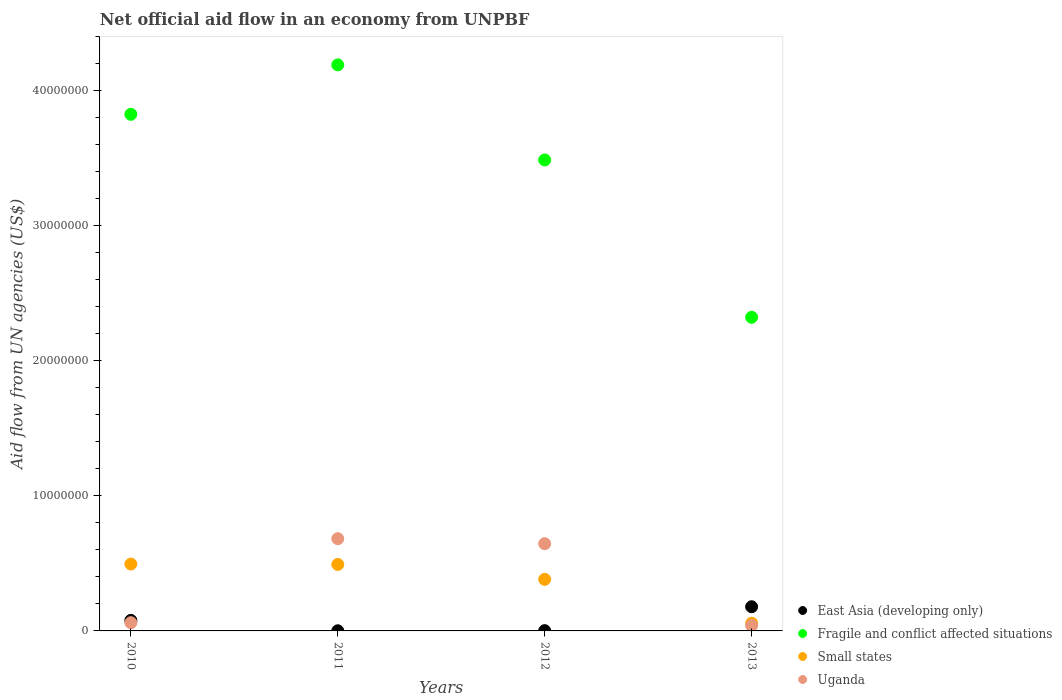What is the net official aid flow in Small states in 2010?
Provide a succinct answer. 4.95e+06. Across all years, what is the maximum net official aid flow in East Asia (developing only)?
Provide a succinct answer. 1.79e+06. Across all years, what is the minimum net official aid flow in Small states?
Offer a very short reply. 5.70e+05. In which year was the net official aid flow in Small states minimum?
Your answer should be compact. 2013. What is the total net official aid flow in Uganda in the graph?
Offer a very short reply. 1.43e+07. What is the difference between the net official aid flow in Uganda in 2011 and that in 2012?
Your answer should be very brief. 3.70e+05. What is the difference between the net official aid flow in Fragile and conflict affected situations in 2010 and the net official aid flow in Small states in 2012?
Make the answer very short. 3.44e+07. What is the average net official aid flow in East Asia (developing only) per year?
Keep it short and to the point. 6.50e+05. In the year 2012, what is the difference between the net official aid flow in Uganda and net official aid flow in East Asia (developing only)?
Provide a short and direct response. 6.44e+06. What is the ratio of the net official aid flow in East Asia (developing only) in 2010 to that in 2013?
Your answer should be very brief. 0.44. Is the net official aid flow in Fragile and conflict affected situations in 2010 less than that in 2013?
Provide a short and direct response. No. What is the difference between the highest and the second highest net official aid flow in East Asia (developing only)?
Provide a short and direct response. 1.01e+06. What is the difference between the highest and the lowest net official aid flow in Fragile and conflict affected situations?
Give a very brief answer. 1.87e+07. Is the sum of the net official aid flow in Uganda in 2012 and 2013 greater than the maximum net official aid flow in Fragile and conflict affected situations across all years?
Provide a short and direct response. No. Is it the case that in every year, the sum of the net official aid flow in Small states and net official aid flow in Uganda  is greater than the sum of net official aid flow in Fragile and conflict affected situations and net official aid flow in East Asia (developing only)?
Give a very brief answer. No. Is the net official aid flow in Fragile and conflict affected situations strictly greater than the net official aid flow in East Asia (developing only) over the years?
Ensure brevity in your answer.  Yes. Is the net official aid flow in East Asia (developing only) strictly less than the net official aid flow in Uganda over the years?
Give a very brief answer. No. How many dotlines are there?
Keep it short and to the point. 4. What is the difference between two consecutive major ticks on the Y-axis?
Provide a succinct answer. 1.00e+07. Does the graph contain any zero values?
Provide a short and direct response. No. Where does the legend appear in the graph?
Offer a terse response. Bottom right. How many legend labels are there?
Provide a succinct answer. 4. What is the title of the graph?
Provide a succinct answer. Net official aid flow in an economy from UNPBF. Does "Norway" appear as one of the legend labels in the graph?
Offer a terse response. No. What is the label or title of the X-axis?
Offer a very short reply. Years. What is the label or title of the Y-axis?
Provide a short and direct response. Aid flow from UN agencies (US$). What is the Aid flow from UN agencies (US$) of East Asia (developing only) in 2010?
Ensure brevity in your answer.  7.80e+05. What is the Aid flow from UN agencies (US$) in Fragile and conflict affected situations in 2010?
Provide a short and direct response. 3.82e+07. What is the Aid flow from UN agencies (US$) of Small states in 2010?
Provide a succinct answer. 4.95e+06. What is the Aid flow from UN agencies (US$) of Uganda in 2010?
Give a very brief answer. 6.10e+05. What is the Aid flow from UN agencies (US$) in Fragile and conflict affected situations in 2011?
Your response must be concise. 4.19e+07. What is the Aid flow from UN agencies (US$) in Small states in 2011?
Provide a succinct answer. 4.92e+06. What is the Aid flow from UN agencies (US$) of Uganda in 2011?
Offer a terse response. 6.83e+06. What is the Aid flow from UN agencies (US$) in Fragile and conflict affected situations in 2012?
Keep it short and to the point. 3.49e+07. What is the Aid flow from UN agencies (US$) in Small states in 2012?
Offer a terse response. 3.82e+06. What is the Aid flow from UN agencies (US$) of Uganda in 2012?
Keep it short and to the point. 6.46e+06. What is the Aid flow from UN agencies (US$) in East Asia (developing only) in 2013?
Make the answer very short. 1.79e+06. What is the Aid flow from UN agencies (US$) of Fragile and conflict affected situations in 2013?
Make the answer very short. 2.32e+07. What is the Aid flow from UN agencies (US$) of Small states in 2013?
Provide a succinct answer. 5.70e+05. Across all years, what is the maximum Aid flow from UN agencies (US$) in East Asia (developing only)?
Provide a short and direct response. 1.79e+06. Across all years, what is the maximum Aid flow from UN agencies (US$) in Fragile and conflict affected situations?
Your answer should be compact. 4.19e+07. Across all years, what is the maximum Aid flow from UN agencies (US$) of Small states?
Make the answer very short. 4.95e+06. Across all years, what is the maximum Aid flow from UN agencies (US$) of Uganda?
Your response must be concise. 6.83e+06. Across all years, what is the minimum Aid flow from UN agencies (US$) of Fragile and conflict affected situations?
Give a very brief answer. 2.32e+07. Across all years, what is the minimum Aid flow from UN agencies (US$) in Small states?
Your response must be concise. 5.70e+05. Across all years, what is the minimum Aid flow from UN agencies (US$) in Uganda?
Make the answer very short. 4.00e+05. What is the total Aid flow from UN agencies (US$) in East Asia (developing only) in the graph?
Give a very brief answer. 2.60e+06. What is the total Aid flow from UN agencies (US$) in Fragile and conflict affected situations in the graph?
Provide a succinct answer. 1.38e+08. What is the total Aid flow from UN agencies (US$) in Small states in the graph?
Make the answer very short. 1.43e+07. What is the total Aid flow from UN agencies (US$) in Uganda in the graph?
Your answer should be compact. 1.43e+07. What is the difference between the Aid flow from UN agencies (US$) of East Asia (developing only) in 2010 and that in 2011?
Your answer should be compact. 7.70e+05. What is the difference between the Aid flow from UN agencies (US$) in Fragile and conflict affected situations in 2010 and that in 2011?
Give a very brief answer. -3.66e+06. What is the difference between the Aid flow from UN agencies (US$) in Small states in 2010 and that in 2011?
Make the answer very short. 3.00e+04. What is the difference between the Aid flow from UN agencies (US$) of Uganda in 2010 and that in 2011?
Your answer should be compact. -6.22e+06. What is the difference between the Aid flow from UN agencies (US$) of East Asia (developing only) in 2010 and that in 2012?
Keep it short and to the point. 7.60e+05. What is the difference between the Aid flow from UN agencies (US$) of Fragile and conflict affected situations in 2010 and that in 2012?
Your answer should be compact. 3.38e+06. What is the difference between the Aid flow from UN agencies (US$) in Small states in 2010 and that in 2012?
Your answer should be very brief. 1.13e+06. What is the difference between the Aid flow from UN agencies (US$) in Uganda in 2010 and that in 2012?
Your answer should be compact. -5.85e+06. What is the difference between the Aid flow from UN agencies (US$) of East Asia (developing only) in 2010 and that in 2013?
Provide a succinct answer. -1.01e+06. What is the difference between the Aid flow from UN agencies (US$) of Fragile and conflict affected situations in 2010 and that in 2013?
Your response must be concise. 1.50e+07. What is the difference between the Aid flow from UN agencies (US$) in Small states in 2010 and that in 2013?
Ensure brevity in your answer.  4.38e+06. What is the difference between the Aid flow from UN agencies (US$) of Uganda in 2010 and that in 2013?
Give a very brief answer. 2.10e+05. What is the difference between the Aid flow from UN agencies (US$) of East Asia (developing only) in 2011 and that in 2012?
Provide a succinct answer. -10000. What is the difference between the Aid flow from UN agencies (US$) of Fragile and conflict affected situations in 2011 and that in 2012?
Provide a succinct answer. 7.04e+06. What is the difference between the Aid flow from UN agencies (US$) in Small states in 2011 and that in 2012?
Provide a short and direct response. 1.10e+06. What is the difference between the Aid flow from UN agencies (US$) in East Asia (developing only) in 2011 and that in 2013?
Provide a short and direct response. -1.78e+06. What is the difference between the Aid flow from UN agencies (US$) in Fragile and conflict affected situations in 2011 and that in 2013?
Ensure brevity in your answer.  1.87e+07. What is the difference between the Aid flow from UN agencies (US$) in Small states in 2011 and that in 2013?
Your answer should be compact. 4.35e+06. What is the difference between the Aid flow from UN agencies (US$) of Uganda in 2011 and that in 2013?
Make the answer very short. 6.43e+06. What is the difference between the Aid flow from UN agencies (US$) of East Asia (developing only) in 2012 and that in 2013?
Your answer should be very brief. -1.77e+06. What is the difference between the Aid flow from UN agencies (US$) of Fragile and conflict affected situations in 2012 and that in 2013?
Keep it short and to the point. 1.16e+07. What is the difference between the Aid flow from UN agencies (US$) of Small states in 2012 and that in 2013?
Your answer should be very brief. 3.25e+06. What is the difference between the Aid flow from UN agencies (US$) in Uganda in 2012 and that in 2013?
Your answer should be compact. 6.06e+06. What is the difference between the Aid flow from UN agencies (US$) of East Asia (developing only) in 2010 and the Aid flow from UN agencies (US$) of Fragile and conflict affected situations in 2011?
Make the answer very short. -4.11e+07. What is the difference between the Aid flow from UN agencies (US$) in East Asia (developing only) in 2010 and the Aid flow from UN agencies (US$) in Small states in 2011?
Ensure brevity in your answer.  -4.14e+06. What is the difference between the Aid flow from UN agencies (US$) of East Asia (developing only) in 2010 and the Aid flow from UN agencies (US$) of Uganda in 2011?
Your response must be concise. -6.05e+06. What is the difference between the Aid flow from UN agencies (US$) in Fragile and conflict affected situations in 2010 and the Aid flow from UN agencies (US$) in Small states in 2011?
Ensure brevity in your answer.  3.33e+07. What is the difference between the Aid flow from UN agencies (US$) in Fragile and conflict affected situations in 2010 and the Aid flow from UN agencies (US$) in Uganda in 2011?
Provide a succinct answer. 3.14e+07. What is the difference between the Aid flow from UN agencies (US$) in Small states in 2010 and the Aid flow from UN agencies (US$) in Uganda in 2011?
Make the answer very short. -1.88e+06. What is the difference between the Aid flow from UN agencies (US$) of East Asia (developing only) in 2010 and the Aid flow from UN agencies (US$) of Fragile and conflict affected situations in 2012?
Provide a succinct answer. -3.41e+07. What is the difference between the Aid flow from UN agencies (US$) of East Asia (developing only) in 2010 and the Aid flow from UN agencies (US$) of Small states in 2012?
Keep it short and to the point. -3.04e+06. What is the difference between the Aid flow from UN agencies (US$) of East Asia (developing only) in 2010 and the Aid flow from UN agencies (US$) of Uganda in 2012?
Provide a short and direct response. -5.68e+06. What is the difference between the Aid flow from UN agencies (US$) of Fragile and conflict affected situations in 2010 and the Aid flow from UN agencies (US$) of Small states in 2012?
Give a very brief answer. 3.44e+07. What is the difference between the Aid flow from UN agencies (US$) in Fragile and conflict affected situations in 2010 and the Aid flow from UN agencies (US$) in Uganda in 2012?
Your answer should be compact. 3.18e+07. What is the difference between the Aid flow from UN agencies (US$) in Small states in 2010 and the Aid flow from UN agencies (US$) in Uganda in 2012?
Make the answer very short. -1.51e+06. What is the difference between the Aid flow from UN agencies (US$) in East Asia (developing only) in 2010 and the Aid flow from UN agencies (US$) in Fragile and conflict affected situations in 2013?
Make the answer very short. -2.24e+07. What is the difference between the Aid flow from UN agencies (US$) of Fragile and conflict affected situations in 2010 and the Aid flow from UN agencies (US$) of Small states in 2013?
Your response must be concise. 3.77e+07. What is the difference between the Aid flow from UN agencies (US$) in Fragile and conflict affected situations in 2010 and the Aid flow from UN agencies (US$) in Uganda in 2013?
Provide a succinct answer. 3.78e+07. What is the difference between the Aid flow from UN agencies (US$) of Small states in 2010 and the Aid flow from UN agencies (US$) of Uganda in 2013?
Make the answer very short. 4.55e+06. What is the difference between the Aid flow from UN agencies (US$) in East Asia (developing only) in 2011 and the Aid flow from UN agencies (US$) in Fragile and conflict affected situations in 2012?
Provide a short and direct response. -3.49e+07. What is the difference between the Aid flow from UN agencies (US$) of East Asia (developing only) in 2011 and the Aid flow from UN agencies (US$) of Small states in 2012?
Your answer should be very brief. -3.81e+06. What is the difference between the Aid flow from UN agencies (US$) in East Asia (developing only) in 2011 and the Aid flow from UN agencies (US$) in Uganda in 2012?
Give a very brief answer. -6.45e+06. What is the difference between the Aid flow from UN agencies (US$) in Fragile and conflict affected situations in 2011 and the Aid flow from UN agencies (US$) in Small states in 2012?
Offer a terse response. 3.81e+07. What is the difference between the Aid flow from UN agencies (US$) in Fragile and conflict affected situations in 2011 and the Aid flow from UN agencies (US$) in Uganda in 2012?
Provide a short and direct response. 3.54e+07. What is the difference between the Aid flow from UN agencies (US$) in Small states in 2011 and the Aid flow from UN agencies (US$) in Uganda in 2012?
Keep it short and to the point. -1.54e+06. What is the difference between the Aid flow from UN agencies (US$) of East Asia (developing only) in 2011 and the Aid flow from UN agencies (US$) of Fragile and conflict affected situations in 2013?
Keep it short and to the point. -2.32e+07. What is the difference between the Aid flow from UN agencies (US$) in East Asia (developing only) in 2011 and the Aid flow from UN agencies (US$) in Small states in 2013?
Ensure brevity in your answer.  -5.60e+05. What is the difference between the Aid flow from UN agencies (US$) of East Asia (developing only) in 2011 and the Aid flow from UN agencies (US$) of Uganda in 2013?
Your answer should be very brief. -3.90e+05. What is the difference between the Aid flow from UN agencies (US$) in Fragile and conflict affected situations in 2011 and the Aid flow from UN agencies (US$) in Small states in 2013?
Provide a short and direct response. 4.13e+07. What is the difference between the Aid flow from UN agencies (US$) of Fragile and conflict affected situations in 2011 and the Aid flow from UN agencies (US$) of Uganda in 2013?
Provide a short and direct response. 4.15e+07. What is the difference between the Aid flow from UN agencies (US$) in Small states in 2011 and the Aid flow from UN agencies (US$) in Uganda in 2013?
Keep it short and to the point. 4.52e+06. What is the difference between the Aid flow from UN agencies (US$) in East Asia (developing only) in 2012 and the Aid flow from UN agencies (US$) in Fragile and conflict affected situations in 2013?
Give a very brief answer. -2.32e+07. What is the difference between the Aid flow from UN agencies (US$) in East Asia (developing only) in 2012 and the Aid flow from UN agencies (US$) in Small states in 2013?
Give a very brief answer. -5.50e+05. What is the difference between the Aid flow from UN agencies (US$) of East Asia (developing only) in 2012 and the Aid flow from UN agencies (US$) of Uganda in 2013?
Offer a very short reply. -3.80e+05. What is the difference between the Aid flow from UN agencies (US$) of Fragile and conflict affected situations in 2012 and the Aid flow from UN agencies (US$) of Small states in 2013?
Your answer should be compact. 3.43e+07. What is the difference between the Aid flow from UN agencies (US$) of Fragile and conflict affected situations in 2012 and the Aid flow from UN agencies (US$) of Uganda in 2013?
Provide a succinct answer. 3.45e+07. What is the difference between the Aid flow from UN agencies (US$) in Small states in 2012 and the Aid flow from UN agencies (US$) in Uganda in 2013?
Give a very brief answer. 3.42e+06. What is the average Aid flow from UN agencies (US$) in East Asia (developing only) per year?
Give a very brief answer. 6.50e+05. What is the average Aid flow from UN agencies (US$) in Fragile and conflict affected situations per year?
Your answer should be very brief. 3.46e+07. What is the average Aid flow from UN agencies (US$) in Small states per year?
Give a very brief answer. 3.56e+06. What is the average Aid flow from UN agencies (US$) in Uganda per year?
Offer a terse response. 3.58e+06. In the year 2010, what is the difference between the Aid flow from UN agencies (US$) in East Asia (developing only) and Aid flow from UN agencies (US$) in Fragile and conflict affected situations?
Provide a succinct answer. -3.75e+07. In the year 2010, what is the difference between the Aid flow from UN agencies (US$) in East Asia (developing only) and Aid flow from UN agencies (US$) in Small states?
Keep it short and to the point. -4.17e+06. In the year 2010, what is the difference between the Aid flow from UN agencies (US$) in Fragile and conflict affected situations and Aid flow from UN agencies (US$) in Small states?
Your response must be concise. 3.33e+07. In the year 2010, what is the difference between the Aid flow from UN agencies (US$) of Fragile and conflict affected situations and Aid flow from UN agencies (US$) of Uganda?
Keep it short and to the point. 3.76e+07. In the year 2010, what is the difference between the Aid flow from UN agencies (US$) of Small states and Aid flow from UN agencies (US$) of Uganda?
Make the answer very short. 4.34e+06. In the year 2011, what is the difference between the Aid flow from UN agencies (US$) of East Asia (developing only) and Aid flow from UN agencies (US$) of Fragile and conflict affected situations?
Keep it short and to the point. -4.19e+07. In the year 2011, what is the difference between the Aid flow from UN agencies (US$) of East Asia (developing only) and Aid flow from UN agencies (US$) of Small states?
Offer a very short reply. -4.91e+06. In the year 2011, what is the difference between the Aid flow from UN agencies (US$) of East Asia (developing only) and Aid flow from UN agencies (US$) of Uganda?
Keep it short and to the point. -6.82e+06. In the year 2011, what is the difference between the Aid flow from UN agencies (US$) in Fragile and conflict affected situations and Aid flow from UN agencies (US$) in Small states?
Your answer should be compact. 3.70e+07. In the year 2011, what is the difference between the Aid flow from UN agencies (US$) of Fragile and conflict affected situations and Aid flow from UN agencies (US$) of Uganda?
Provide a succinct answer. 3.51e+07. In the year 2011, what is the difference between the Aid flow from UN agencies (US$) in Small states and Aid flow from UN agencies (US$) in Uganda?
Keep it short and to the point. -1.91e+06. In the year 2012, what is the difference between the Aid flow from UN agencies (US$) in East Asia (developing only) and Aid flow from UN agencies (US$) in Fragile and conflict affected situations?
Give a very brief answer. -3.48e+07. In the year 2012, what is the difference between the Aid flow from UN agencies (US$) of East Asia (developing only) and Aid flow from UN agencies (US$) of Small states?
Make the answer very short. -3.80e+06. In the year 2012, what is the difference between the Aid flow from UN agencies (US$) of East Asia (developing only) and Aid flow from UN agencies (US$) of Uganda?
Your answer should be compact. -6.44e+06. In the year 2012, what is the difference between the Aid flow from UN agencies (US$) of Fragile and conflict affected situations and Aid flow from UN agencies (US$) of Small states?
Your answer should be compact. 3.10e+07. In the year 2012, what is the difference between the Aid flow from UN agencies (US$) in Fragile and conflict affected situations and Aid flow from UN agencies (US$) in Uganda?
Keep it short and to the point. 2.84e+07. In the year 2012, what is the difference between the Aid flow from UN agencies (US$) in Small states and Aid flow from UN agencies (US$) in Uganda?
Your answer should be compact. -2.64e+06. In the year 2013, what is the difference between the Aid flow from UN agencies (US$) in East Asia (developing only) and Aid flow from UN agencies (US$) in Fragile and conflict affected situations?
Provide a short and direct response. -2.14e+07. In the year 2013, what is the difference between the Aid flow from UN agencies (US$) of East Asia (developing only) and Aid flow from UN agencies (US$) of Small states?
Keep it short and to the point. 1.22e+06. In the year 2013, what is the difference between the Aid flow from UN agencies (US$) in East Asia (developing only) and Aid flow from UN agencies (US$) in Uganda?
Your answer should be compact. 1.39e+06. In the year 2013, what is the difference between the Aid flow from UN agencies (US$) in Fragile and conflict affected situations and Aid flow from UN agencies (US$) in Small states?
Your answer should be compact. 2.26e+07. In the year 2013, what is the difference between the Aid flow from UN agencies (US$) of Fragile and conflict affected situations and Aid flow from UN agencies (US$) of Uganda?
Your answer should be compact. 2.28e+07. In the year 2013, what is the difference between the Aid flow from UN agencies (US$) in Small states and Aid flow from UN agencies (US$) in Uganda?
Provide a succinct answer. 1.70e+05. What is the ratio of the Aid flow from UN agencies (US$) in Fragile and conflict affected situations in 2010 to that in 2011?
Offer a very short reply. 0.91. What is the ratio of the Aid flow from UN agencies (US$) in Uganda in 2010 to that in 2011?
Your answer should be compact. 0.09. What is the ratio of the Aid flow from UN agencies (US$) of East Asia (developing only) in 2010 to that in 2012?
Your response must be concise. 39. What is the ratio of the Aid flow from UN agencies (US$) of Fragile and conflict affected situations in 2010 to that in 2012?
Keep it short and to the point. 1.1. What is the ratio of the Aid flow from UN agencies (US$) of Small states in 2010 to that in 2012?
Your answer should be compact. 1.3. What is the ratio of the Aid flow from UN agencies (US$) of Uganda in 2010 to that in 2012?
Ensure brevity in your answer.  0.09. What is the ratio of the Aid flow from UN agencies (US$) of East Asia (developing only) in 2010 to that in 2013?
Offer a very short reply. 0.44. What is the ratio of the Aid flow from UN agencies (US$) of Fragile and conflict affected situations in 2010 to that in 2013?
Your answer should be very brief. 1.65. What is the ratio of the Aid flow from UN agencies (US$) of Small states in 2010 to that in 2013?
Ensure brevity in your answer.  8.68. What is the ratio of the Aid flow from UN agencies (US$) of Uganda in 2010 to that in 2013?
Your answer should be very brief. 1.52. What is the ratio of the Aid flow from UN agencies (US$) in East Asia (developing only) in 2011 to that in 2012?
Keep it short and to the point. 0.5. What is the ratio of the Aid flow from UN agencies (US$) of Fragile and conflict affected situations in 2011 to that in 2012?
Your answer should be very brief. 1.2. What is the ratio of the Aid flow from UN agencies (US$) of Small states in 2011 to that in 2012?
Ensure brevity in your answer.  1.29. What is the ratio of the Aid flow from UN agencies (US$) of Uganda in 2011 to that in 2012?
Offer a terse response. 1.06. What is the ratio of the Aid flow from UN agencies (US$) of East Asia (developing only) in 2011 to that in 2013?
Ensure brevity in your answer.  0.01. What is the ratio of the Aid flow from UN agencies (US$) of Fragile and conflict affected situations in 2011 to that in 2013?
Your answer should be compact. 1.8. What is the ratio of the Aid flow from UN agencies (US$) in Small states in 2011 to that in 2013?
Your response must be concise. 8.63. What is the ratio of the Aid flow from UN agencies (US$) in Uganda in 2011 to that in 2013?
Your answer should be very brief. 17.07. What is the ratio of the Aid flow from UN agencies (US$) in East Asia (developing only) in 2012 to that in 2013?
Give a very brief answer. 0.01. What is the ratio of the Aid flow from UN agencies (US$) in Fragile and conflict affected situations in 2012 to that in 2013?
Provide a short and direct response. 1.5. What is the ratio of the Aid flow from UN agencies (US$) of Small states in 2012 to that in 2013?
Make the answer very short. 6.7. What is the ratio of the Aid flow from UN agencies (US$) in Uganda in 2012 to that in 2013?
Make the answer very short. 16.15. What is the difference between the highest and the second highest Aid flow from UN agencies (US$) in East Asia (developing only)?
Offer a very short reply. 1.01e+06. What is the difference between the highest and the second highest Aid flow from UN agencies (US$) in Fragile and conflict affected situations?
Your answer should be compact. 3.66e+06. What is the difference between the highest and the second highest Aid flow from UN agencies (US$) of Small states?
Offer a terse response. 3.00e+04. What is the difference between the highest and the second highest Aid flow from UN agencies (US$) of Uganda?
Offer a terse response. 3.70e+05. What is the difference between the highest and the lowest Aid flow from UN agencies (US$) of East Asia (developing only)?
Your response must be concise. 1.78e+06. What is the difference between the highest and the lowest Aid flow from UN agencies (US$) in Fragile and conflict affected situations?
Provide a short and direct response. 1.87e+07. What is the difference between the highest and the lowest Aid flow from UN agencies (US$) in Small states?
Offer a very short reply. 4.38e+06. What is the difference between the highest and the lowest Aid flow from UN agencies (US$) in Uganda?
Your answer should be very brief. 6.43e+06. 